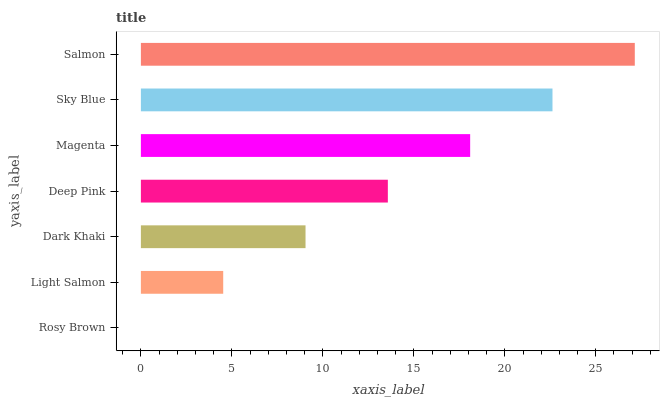Is Rosy Brown the minimum?
Answer yes or no. Yes. Is Salmon the maximum?
Answer yes or no. Yes. Is Light Salmon the minimum?
Answer yes or no. No. Is Light Salmon the maximum?
Answer yes or no. No. Is Light Salmon greater than Rosy Brown?
Answer yes or no. Yes. Is Rosy Brown less than Light Salmon?
Answer yes or no. Yes. Is Rosy Brown greater than Light Salmon?
Answer yes or no. No. Is Light Salmon less than Rosy Brown?
Answer yes or no. No. Is Deep Pink the high median?
Answer yes or no. Yes. Is Deep Pink the low median?
Answer yes or no. Yes. Is Light Salmon the high median?
Answer yes or no. No. Is Dark Khaki the low median?
Answer yes or no. No. 